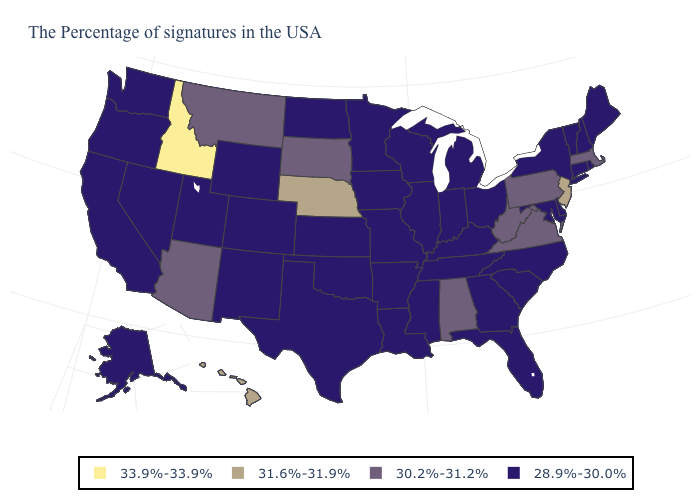What is the highest value in the MidWest ?
Quick response, please. 31.6%-31.9%. What is the value of Louisiana?
Quick response, please. 28.9%-30.0%. What is the value of Kansas?
Concise answer only. 28.9%-30.0%. Name the states that have a value in the range 33.9%-33.9%?
Be succinct. Idaho. Among the states that border Missouri , which have the lowest value?
Keep it brief. Kentucky, Tennessee, Illinois, Arkansas, Iowa, Kansas, Oklahoma. Does the map have missing data?
Quick response, please. No. Name the states that have a value in the range 30.2%-31.2%?
Answer briefly. Massachusetts, Pennsylvania, Virginia, West Virginia, Alabama, South Dakota, Montana, Arizona. Does South Dakota have the lowest value in the MidWest?
Keep it brief. No. Does Virginia have the highest value in the South?
Write a very short answer. Yes. What is the value of Massachusetts?
Quick response, please. 30.2%-31.2%. What is the value of South Dakota?
Be succinct. 30.2%-31.2%. Name the states that have a value in the range 33.9%-33.9%?
Concise answer only. Idaho. Which states hav the highest value in the West?
Quick response, please. Idaho. What is the highest value in the MidWest ?
Write a very short answer. 31.6%-31.9%. 